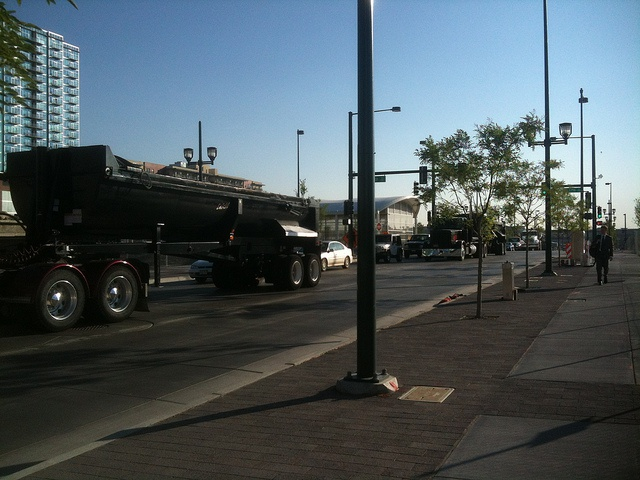Describe the objects in this image and their specific colors. I can see truck in blue, black, gray, and darkgray tones, truck in blue, black, gray, and maroon tones, people in blue, black, and gray tones, car in blue, ivory, black, darkgray, and gray tones, and car in blue, black, gray, darkgray, and lightgray tones in this image. 